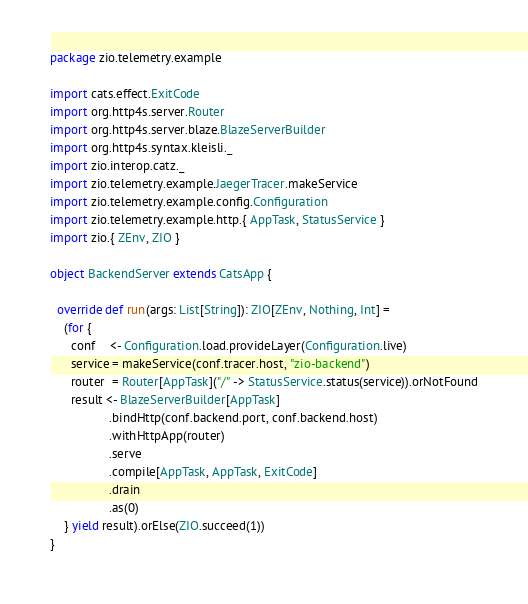Convert code to text. <code><loc_0><loc_0><loc_500><loc_500><_Scala_>package zio.telemetry.example

import cats.effect.ExitCode
import org.http4s.server.Router
import org.http4s.server.blaze.BlazeServerBuilder
import org.http4s.syntax.kleisli._
import zio.interop.catz._
import zio.telemetry.example.JaegerTracer.makeService
import zio.telemetry.example.config.Configuration
import zio.telemetry.example.http.{ AppTask, StatusService }
import zio.{ ZEnv, ZIO }

object BackendServer extends CatsApp {

  override def run(args: List[String]): ZIO[ZEnv, Nothing, Int] =
    (for {
      conf    <- Configuration.load.provideLayer(Configuration.live)
      service = makeService(conf.tracer.host, "zio-backend")
      router  = Router[AppTask]("/" -> StatusService.status(service)).orNotFound
      result <- BlazeServerBuilder[AppTask]
                 .bindHttp(conf.backend.port, conf.backend.host)
                 .withHttpApp(router)
                 .serve
                 .compile[AppTask, AppTask, ExitCode]
                 .drain
                 .as(0)
    } yield result).orElse(ZIO.succeed(1))
}
</code> 